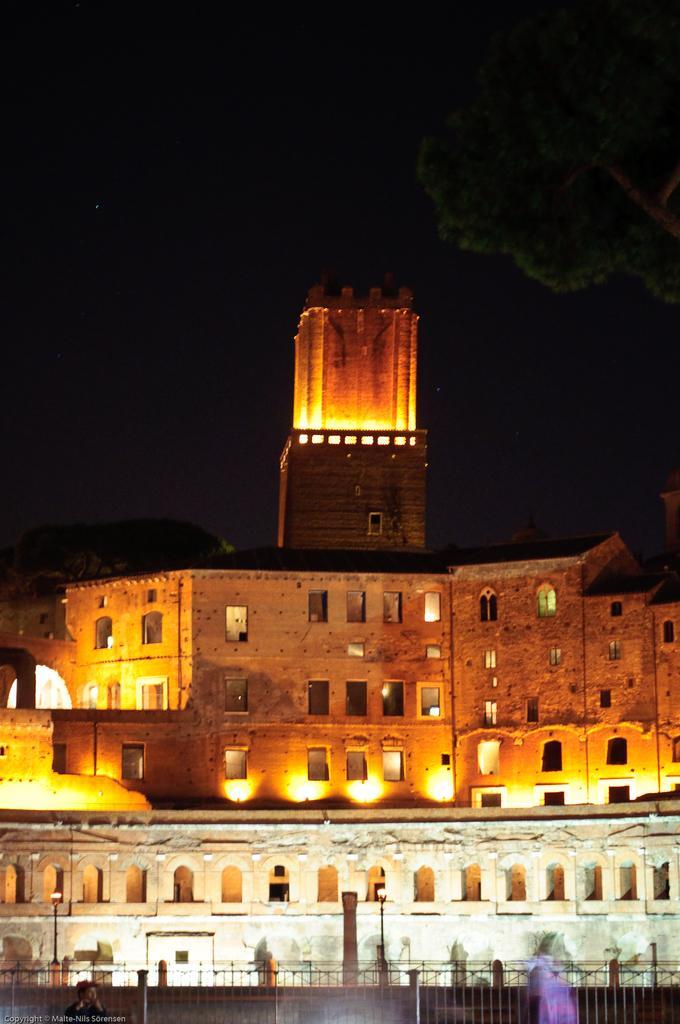How would you summarize this image in a sentence or two? This picture consists of a building , on the building I can see a light focus ,at the bottom there is a building ,at the top there is the sky, it might be the tree visible on the right side, this picture is taken during night. 